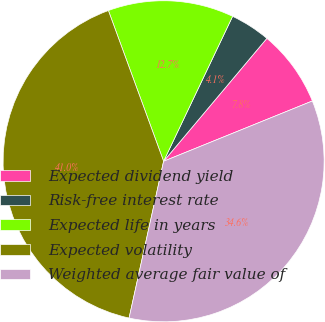<chart> <loc_0><loc_0><loc_500><loc_500><pie_chart><fcel>Expected dividend yield<fcel>Risk-free interest rate<fcel>Expected life in years<fcel>Expected volatility<fcel>Weighted average fair value of<nl><fcel>7.75%<fcel>4.05%<fcel>12.66%<fcel>40.96%<fcel>34.58%<nl></chart> 